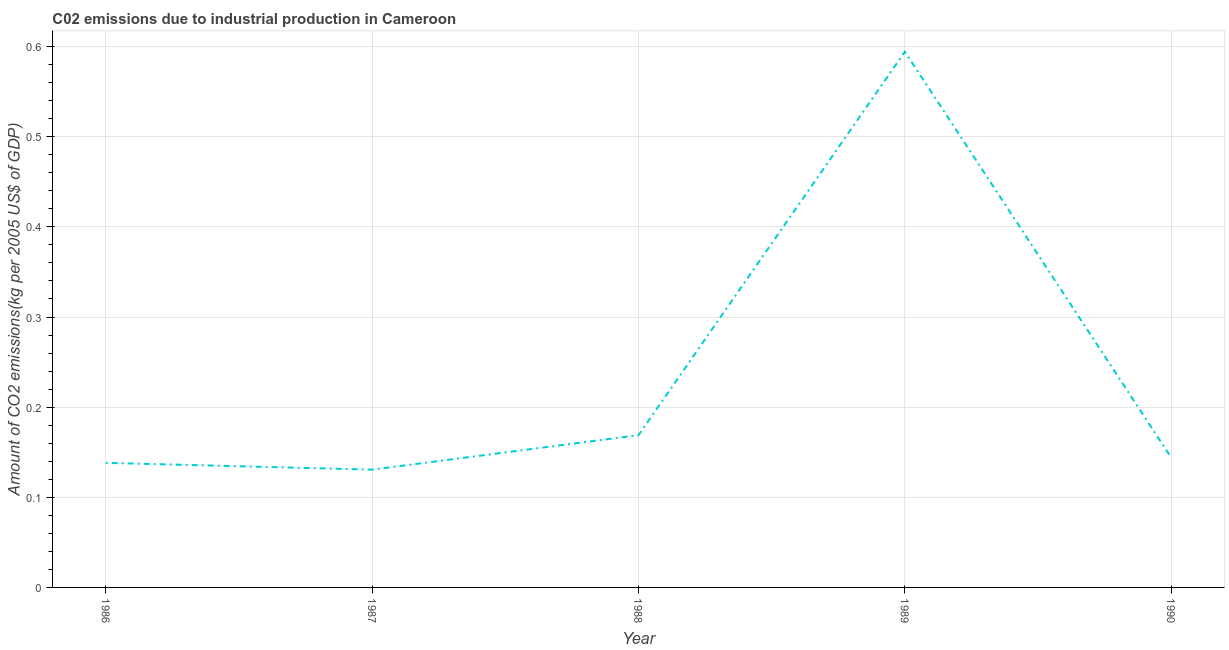What is the amount of co2 emissions in 1990?
Offer a very short reply. 0.14. Across all years, what is the maximum amount of co2 emissions?
Provide a short and direct response. 0.59. Across all years, what is the minimum amount of co2 emissions?
Your answer should be compact. 0.13. In which year was the amount of co2 emissions minimum?
Provide a succinct answer. 1987. What is the sum of the amount of co2 emissions?
Your answer should be very brief. 1.18. What is the difference between the amount of co2 emissions in 1986 and 1990?
Give a very brief answer. -0.01. What is the average amount of co2 emissions per year?
Provide a short and direct response. 0.24. What is the median amount of co2 emissions?
Make the answer very short. 0.14. Do a majority of the years between 1989 and 1987 (inclusive) have amount of co2 emissions greater than 0.48000000000000004 kg per 2005 US$ of GDP?
Provide a succinct answer. No. What is the ratio of the amount of co2 emissions in 1987 to that in 1990?
Your answer should be very brief. 0.91. Is the difference between the amount of co2 emissions in 1987 and 1989 greater than the difference between any two years?
Make the answer very short. Yes. What is the difference between the highest and the second highest amount of co2 emissions?
Keep it short and to the point. 0.43. What is the difference between the highest and the lowest amount of co2 emissions?
Offer a terse response. 0.46. In how many years, is the amount of co2 emissions greater than the average amount of co2 emissions taken over all years?
Your answer should be very brief. 1. Are the values on the major ticks of Y-axis written in scientific E-notation?
Give a very brief answer. No. Does the graph contain any zero values?
Offer a very short reply. No. Does the graph contain grids?
Your answer should be very brief. Yes. What is the title of the graph?
Ensure brevity in your answer.  C02 emissions due to industrial production in Cameroon. What is the label or title of the X-axis?
Ensure brevity in your answer.  Year. What is the label or title of the Y-axis?
Offer a very short reply. Amount of CO2 emissions(kg per 2005 US$ of GDP). What is the Amount of CO2 emissions(kg per 2005 US$ of GDP) of 1986?
Give a very brief answer. 0.14. What is the Amount of CO2 emissions(kg per 2005 US$ of GDP) of 1987?
Your answer should be very brief. 0.13. What is the Amount of CO2 emissions(kg per 2005 US$ of GDP) of 1988?
Provide a succinct answer. 0.17. What is the Amount of CO2 emissions(kg per 2005 US$ of GDP) of 1989?
Ensure brevity in your answer.  0.59. What is the Amount of CO2 emissions(kg per 2005 US$ of GDP) of 1990?
Offer a very short reply. 0.14. What is the difference between the Amount of CO2 emissions(kg per 2005 US$ of GDP) in 1986 and 1987?
Keep it short and to the point. 0.01. What is the difference between the Amount of CO2 emissions(kg per 2005 US$ of GDP) in 1986 and 1988?
Ensure brevity in your answer.  -0.03. What is the difference between the Amount of CO2 emissions(kg per 2005 US$ of GDP) in 1986 and 1989?
Offer a terse response. -0.46. What is the difference between the Amount of CO2 emissions(kg per 2005 US$ of GDP) in 1986 and 1990?
Your answer should be very brief. -0.01. What is the difference between the Amount of CO2 emissions(kg per 2005 US$ of GDP) in 1987 and 1988?
Keep it short and to the point. -0.04. What is the difference between the Amount of CO2 emissions(kg per 2005 US$ of GDP) in 1987 and 1989?
Your answer should be very brief. -0.46. What is the difference between the Amount of CO2 emissions(kg per 2005 US$ of GDP) in 1987 and 1990?
Offer a very short reply. -0.01. What is the difference between the Amount of CO2 emissions(kg per 2005 US$ of GDP) in 1988 and 1989?
Keep it short and to the point. -0.43. What is the difference between the Amount of CO2 emissions(kg per 2005 US$ of GDP) in 1988 and 1990?
Your answer should be very brief. 0.02. What is the difference between the Amount of CO2 emissions(kg per 2005 US$ of GDP) in 1989 and 1990?
Make the answer very short. 0.45. What is the ratio of the Amount of CO2 emissions(kg per 2005 US$ of GDP) in 1986 to that in 1987?
Offer a terse response. 1.06. What is the ratio of the Amount of CO2 emissions(kg per 2005 US$ of GDP) in 1986 to that in 1988?
Offer a very short reply. 0.82. What is the ratio of the Amount of CO2 emissions(kg per 2005 US$ of GDP) in 1986 to that in 1989?
Provide a short and direct response. 0.23. What is the ratio of the Amount of CO2 emissions(kg per 2005 US$ of GDP) in 1987 to that in 1988?
Your response must be concise. 0.77. What is the ratio of the Amount of CO2 emissions(kg per 2005 US$ of GDP) in 1987 to that in 1989?
Ensure brevity in your answer.  0.22. What is the ratio of the Amount of CO2 emissions(kg per 2005 US$ of GDP) in 1987 to that in 1990?
Make the answer very short. 0.91. What is the ratio of the Amount of CO2 emissions(kg per 2005 US$ of GDP) in 1988 to that in 1989?
Offer a terse response. 0.28. What is the ratio of the Amount of CO2 emissions(kg per 2005 US$ of GDP) in 1988 to that in 1990?
Your answer should be compact. 1.17. What is the ratio of the Amount of CO2 emissions(kg per 2005 US$ of GDP) in 1989 to that in 1990?
Provide a succinct answer. 4.13. 